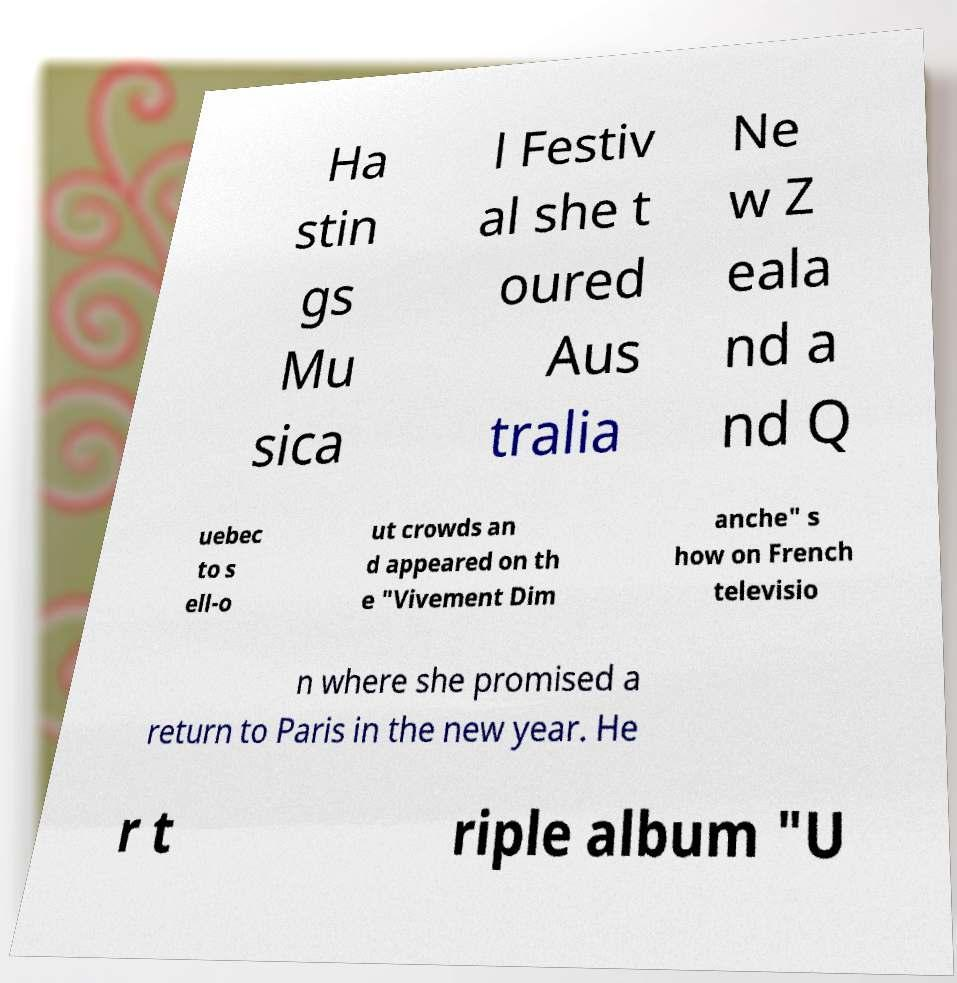Could you extract and type out the text from this image? Ha stin gs Mu sica l Festiv al she t oured Aus tralia Ne w Z eala nd a nd Q uebec to s ell-o ut crowds an d appeared on th e "Vivement Dim anche" s how on French televisio n where she promised a return to Paris in the new year. He r t riple album "U 